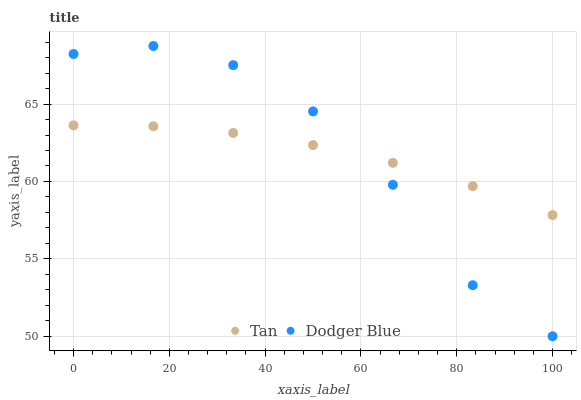Does Tan have the minimum area under the curve?
Answer yes or no. Yes. Does Dodger Blue have the maximum area under the curve?
Answer yes or no. Yes. Does Dodger Blue have the minimum area under the curve?
Answer yes or no. No. Is Tan the smoothest?
Answer yes or no. Yes. Is Dodger Blue the roughest?
Answer yes or no. Yes. Is Dodger Blue the smoothest?
Answer yes or no. No. Does Dodger Blue have the lowest value?
Answer yes or no. Yes. Does Dodger Blue have the highest value?
Answer yes or no. Yes. Does Tan intersect Dodger Blue?
Answer yes or no. Yes. Is Tan less than Dodger Blue?
Answer yes or no. No. Is Tan greater than Dodger Blue?
Answer yes or no. No. 